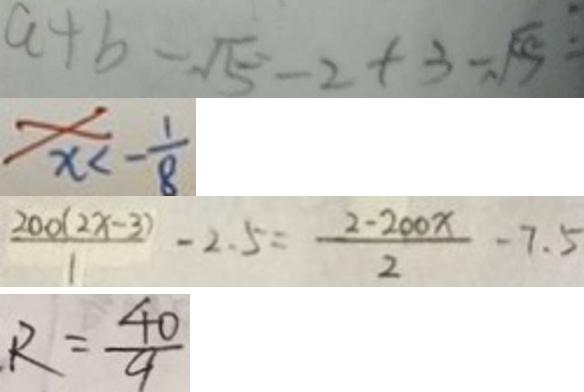Convert formula to latex. <formula><loc_0><loc_0><loc_500><loc_500>a + b - \sqrt { 5 } - 2 + 3 - \sqrt { 5 } : 
 x < - \frac { 1 } { 8 } 
 \frac { 2 0 0 ( 2 x - 3 ) } { 1 } - 2 . 5 = \frac { 2 - 2 0 0 x } { 2 } - 7 . 5 
 R = \frac { 4 0 } { 9 }</formula> 